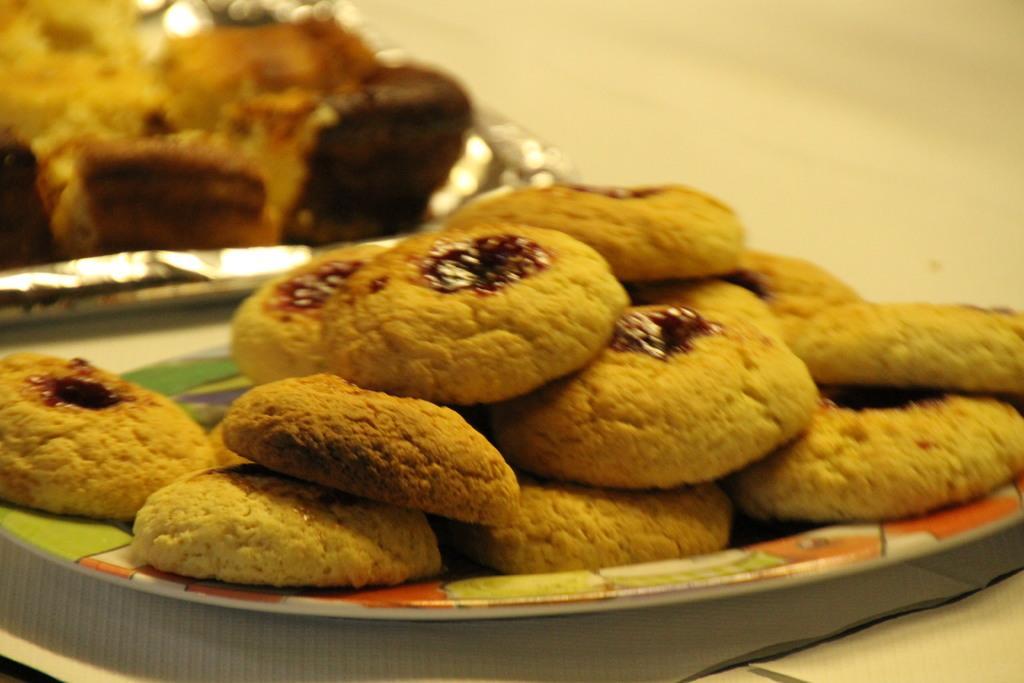Can you describe this image briefly? There are cookies on the plates. And the background is white in color. 